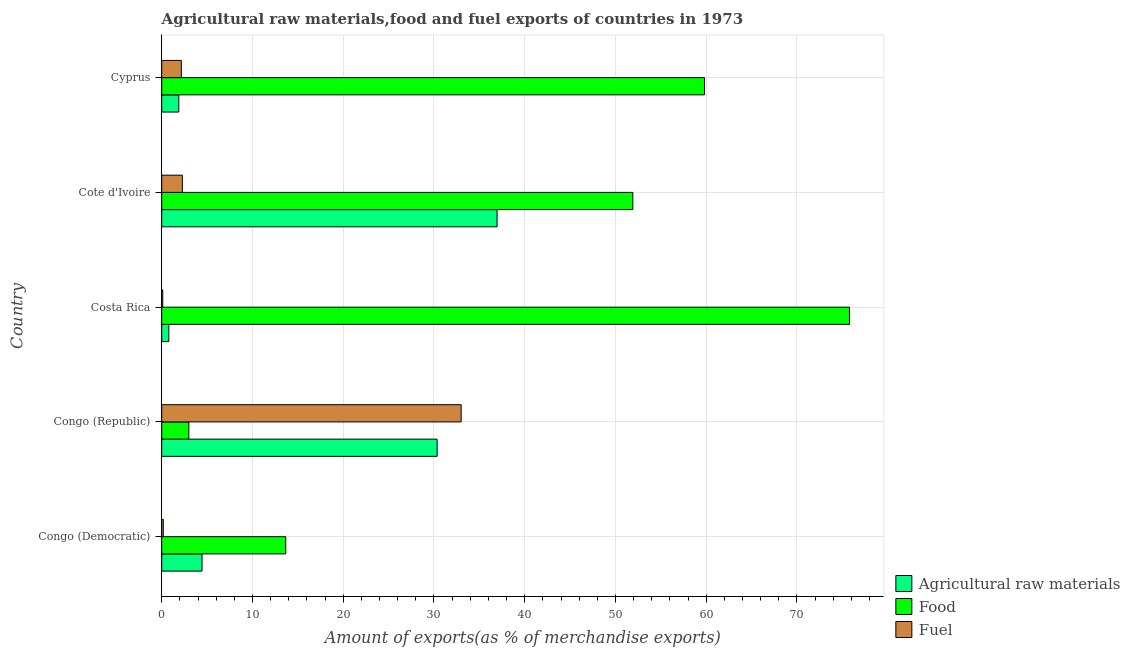How many different coloured bars are there?
Your answer should be very brief. 3. How many groups of bars are there?
Your answer should be very brief. 5. Are the number of bars per tick equal to the number of legend labels?
Provide a succinct answer. Yes. Are the number of bars on each tick of the Y-axis equal?
Make the answer very short. Yes. What is the label of the 1st group of bars from the top?
Offer a terse response. Cyprus. What is the percentage of raw materials exports in Congo (Democratic)?
Keep it short and to the point. 4.44. Across all countries, what is the maximum percentage of food exports?
Make the answer very short. 75.78. Across all countries, what is the minimum percentage of raw materials exports?
Provide a succinct answer. 0.78. In which country was the percentage of food exports maximum?
Your answer should be compact. Costa Rica. In which country was the percentage of food exports minimum?
Keep it short and to the point. Congo (Republic). What is the total percentage of raw materials exports in the graph?
Provide a short and direct response. 74.41. What is the difference between the percentage of raw materials exports in Congo (Democratic) and that in Cote d'Ivoire?
Keep it short and to the point. -32.51. What is the difference between the percentage of fuel exports in Costa Rica and the percentage of raw materials exports in Congo (Democratic)?
Make the answer very short. -4.33. What is the average percentage of fuel exports per country?
Provide a succinct answer. 7.54. What is the difference between the percentage of fuel exports and percentage of food exports in Cote d'Ivoire?
Your response must be concise. -49.63. What is the ratio of the percentage of raw materials exports in Congo (Republic) to that in Costa Rica?
Ensure brevity in your answer.  38.8. What is the difference between the highest and the second highest percentage of fuel exports?
Ensure brevity in your answer.  30.72. What is the difference between the highest and the lowest percentage of fuel exports?
Your answer should be very brief. 32.88. What does the 3rd bar from the top in Cyprus represents?
Your answer should be compact. Agricultural raw materials. What does the 2nd bar from the bottom in Congo (Democratic) represents?
Make the answer very short. Food. How many bars are there?
Your answer should be compact. 15. Are all the bars in the graph horizontal?
Make the answer very short. Yes. How many countries are there in the graph?
Give a very brief answer. 5. Are the values on the major ticks of X-axis written in scientific E-notation?
Offer a terse response. No. Does the graph contain any zero values?
Offer a terse response. No. How many legend labels are there?
Your answer should be very brief. 3. How are the legend labels stacked?
Give a very brief answer. Vertical. What is the title of the graph?
Your answer should be very brief. Agricultural raw materials,food and fuel exports of countries in 1973. Does "Agricultural Nitrous Oxide" appear as one of the legend labels in the graph?
Ensure brevity in your answer.  No. What is the label or title of the X-axis?
Your response must be concise. Amount of exports(as % of merchandise exports). What is the label or title of the Y-axis?
Keep it short and to the point. Country. What is the Amount of exports(as % of merchandise exports) of Agricultural raw materials in Congo (Democratic)?
Keep it short and to the point. 4.44. What is the Amount of exports(as % of merchandise exports) of Food in Congo (Democratic)?
Your answer should be compact. 13.67. What is the Amount of exports(as % of merchandise exports) of Fuel in Congo (Democratic)?
Your answer should be very brief. 0.18. What is the Amount of exports(as % of merchandise exports) of Agricultural raw materials in Congo (Republic)?
Offer a terse response. 30.35. What is the Amount of exports(as % of merchandise exports) of Food in Congo (Republic)?
Provide a short and direct response. 2.99. What is the Amount of exports(as % of merchandise exports) in Fuel in Congo (Republic)?
Offer a terse response. 33. What is the Amount of exports(as % of merchandise exports) of Agricultural raw materials in Costa Rica?
Ensure brevity in your answer.  0.78. What is the Amount of exports(as % of merchandise exports) in Food in Costa Rica?
Provide a succinct answer. 75.78. What is the Amount of exports(as % of merchandise exports) of Fuel in Costa Rica?
Give a very brief answer. 0.11. What is the Amount of exports(as % of merchandise exports) of Agricultural raw materials in Cote d'Ivoire?
Keep it short and to the point. 36.95. What is the Amount of exports(as % of merchandise exports) in Food in Cote d'Ivoire?
Keep it short and to the point. 51.91. What is the Amount of exports(as % of merchandise exports) in Fuel in Cote d'Ivoire?
Offer a very short reply. 2.28. What is the Amount of exports(as % of merchandise exports) in Agricultural raw materials in Cyprus?
Provide a succinct answer. 1.88. What is the Amount of exports(as % of merchandise exports) in Food in Cyprus?
Provide a succinct answer. 59.81. What is the Amount of exports(as % of merchandise exports) of Fuel in Cyprus?
Your answer should be compact. 2.16. Across all countries, what is the maximum Amount of exports(as % of merchandise exports) of Agricultural raw materials?
Offer a terse response. 36.95. Across all countries, what is the maximum Amount of exports(as % of merchandise exports) in Food?
Provide a short and direct response. 75.78. Across all countries, what is the maximum Amount of exports(as % of merchandise exports) of Fuel?
Ensure brevity in your answer.  33. Across all countries, what is the minimum Amount of exports(as % of merchandise exports) of Agricultural raw materials?
Your answer should be very brief. 0.78. Across all countries, what is the minimum Amount of exports(as % of merchandise exports) of Food?
Ensure brevity in your answer.  2.99. Across all countries, what is the minimum Amount of exports(as % of merchandise exports) in Fuel?
Your answer should be compact. 0.11. What is the total Amount of exports(as % of merchandise exports) of Agricultural raw materials in the graph?
Make the answer very short. 74.41. What is the total Amount of exports(as % of merchandise exports) in Food in the graph?
Offer a terse response. 204.15. What is the total Amount of exports(as % of merchandise exports) in Fuel in the graph?
Offer a very short reply. 37.72. What is the difference between the Amount of exports(as % of merchandise exports) of Agricultural raw materials in Congo (Democratic) and that in Congo (Republic)?
Offer a terse response. -25.91. What is the difference between the Amount of exports(as % of merchandise exports) of Food in Congo (Democratic) and that in Congo (Republic)?
Provide a short and direct response. 10.68. What is the difference between the Amount of exports(as % of merchandise exports) in Fuel in Congo (Democratic) and that in Congo (Republic)?
Your response must be concise. -32.82. What is the difference between the Amount of exports(as % of merchandise exports) of Agricultural raw materials in Congo (Democratic) and that in Costa Rica?
Keep it short and to the point. 3.66. What is the difference between the Amount of exports(as % of merchandise exports) in Food in Congo (Democratic) and that in Costa Rica?
Your answer should be very brief. -62.12. What is the difference between the Amount of exports(as % of merchandise exports) of Fuel in Congo (Democratic) and that in Costa Rica?
Keep it short and to the point. 0.06. What is the difference between the Amount of exports(as % of merchandise exports) in Agricultural raw materials in Congo (Democratic) and that in Cote d'Ivoire?
Give a very brief answer. -32.51. What is the difference between the Amount of exports(as % of merchandise exports) in Food in Congo (Democratic) and that in Cote d'Ivoire?
Offer a terse response. -38.25. What is the difference between the Amount of exports(as % of merchandise exports) of Fuel in Congo (Democratic) and that in Cote d'Ivoire?
Make the answer very short. -2.1. What is the difference between the Amount of exports(as % of merchandise exports) in Agricultural raw materials in Congo (Democratic) and that in Cyprus?
Offer a very short reply. 2.56. What is the difference between the Amount of exports(as % of merchandise exports) in Food in Congo (Democratic) and that in Cyprus?
Give a very brief answer. -46.14. What is the difference between the Amount of exports(as % of merchandise exports) of Fuel in Congo (Democratic) and that in Cyprus?
Provide a short and direct response. -1.99. What is the difference between the Amount of exports(as % of merchandise exports) in Agricultural raw materials in Congo (Republic) and that in Costa Rica?
Offer a very short reply. 29.57. What is the difference between the Amount of exports(as % of merchandise exports) in Food in Congo (Republic) and that in Costa Rica?
Your answer should be very brief. -72.79. What is the difference between the Amount of exports(as % of merchandise exports) in Fuel in Congo (Republic) and that in Costa Rica?
Give a very brief answer. 32.88. What is the difference between the Amount of exports(as % of merchandise exports) in Agricultural raw materials in Congo (Republic) and that in Cote d'Ivoire?
Offer a terse response. -6.6. What is the difference between the Amount of exports(as % of merchandise exports) of Food in Congo (Republic) and that in Cote d'Ivoire?
Ensure brevity in your answer.  -48.92. What is the difference between the Amount of exports(as % of merchandise exports) of Fuel in Congo (Republic) and that in Cote d'Ivoire?
Ensure brevity in your answer.  30.72. What is the difference between the Amount of exports(as % of merchandise exports) of Agricultural raw materials in Congo (Republic) and that in Cyprus?
Keep it short and to the point. 28.47. What is the difference between the Amount of exports(as % of merchandise exports) in Food in Congo (Republic) and that in Cyprus?
Your answer should be very brief. -56.82. What is the difference between the Amount of exports(as % of merchandise exports) in Fuel in Congo (Republic) and that in Cyprus?
Give a very brief answer. 30.83. What is the difference between the Amount of exports(as % of merchandise exports) in Agricultural raw materials in Costa Rica and that in Cote d'Ivoire?
Your answer should be compact. -36.17. What is the difference between the Amount of exports(as % of merchandise exports) of Food in Costa Rica and that in Cote d'Ivoire?
Ensure brevity in your answer.  23.87. What is the difference between the Amount of exports(as % of merchandise exports) in Fuel in Costa Rica and that in Cote d'Ivoire?
Your response must be concise. -2.16. What is the difference between the Amount of exports(as % of merchandise exports) in Agricultural raw materials in Costa Rica and that in Cyprus?
Offer a terse response. -1.1. What is the difference between the Amount of exports(as % of merchandise exports) of Food in Costa Rica and that in Cyprus?
Your answer should be compact. 15.97. What is the difference between the Amount of exports(as % of merchandise exports) of Fuel in Costa Rica and that in Cyprus?
Provide a succinct answer. -2.05. What is the difference between the Amount of exports(as % of merchandise exports) in Agricultural raw materials in Cote d'Ivoire and that in Cyprus?
Make the answer very short. 35.07. What is the difference between the Amount of exports(as % of merchandise exports) in Food in Cote d'Ivoire and that in Cyprus?
Make the answer very short. -7.9. What is the difference between the Amount of exports(as % of merchandise exports) of Fuel in Cote d'Ivoire and that in Cyprus?
Make the answer very short. 0.12. What is the difference between the Amount of exports(as % of merchandise exports) in Agricultural raw materials in Congo (Democratic) and the Amount of exports(as % of merchandise exports) in Food in Congo (Republic)?
Offer a terse response. 1.45. What is the difference between the Amount of exports(as % of merchandise exports) in Agricultural raw materials in Congo (Democratic) and the Amount of exports(as % of merchandise exports) in Fuel in Congo (Republic)?
Your response must be concise. -28.55. What is the difference between the Amount of exports(as % of merchandise exports) of Food in Congo (Democratic) and the Amount of exports(as % of merchandise exports) of Fuel in Congo (Republic)?
Offer a terse response. -19.33. What is the difference between the Amount of exports(as % of merchandise exports) in Agricultural raw materials in Congo (Democratic) and the Amount of exports(as % of merchandise exports) in Food in Costa Rica?
Ensure brevity in your answer.  -71.34. What is the difference between the Amount of exports(as % of merchandise exports) of Agricultural raw materials in Congo (Democratic) and the Amount of exports(as % of merchandise exports) of Fuel in Costa Rica?
Ensure brevity in your answer.  4.33. What is the difference between the Amount of exports(as % of merchandise exports) of Food in Congo (Democratic) and the Amount of exports(as % of merchandise exports) of Fuel in Costa Rica?
Offer a terse response. 13.55. What is the difference between the Amount of exports(as % of merchandise exports) of Agricultural raw materials in Congo (Democratic) and the Amount of exports(as % of merchandise exports) of Food in Cote d'Ivoire?
Make the answer very short. -47.47. What is the difference between the Amount of exports(as % of merchandise exports) in Agricultural raw materials in Congo (Democratic) and the Amount of exports(as % of merchandise exports) in Fuel in Cote d'Ivoire?
Ensure brevity in your answer.  2.16. What is the difference between the Amount of exports(as % of merchandise exports) of Food in Congo (Democratic) and the Amount of exports(as % of merchandise exports) of Fuel in Cote d'Ivoire?
Provide a short and direct response. 11.39. What is the difference between the Amount of exports(as % of merchandise exports) of Agricultural raw materials in Congo (Democratic) and the Amount of exports(as % of merchandise exports) of Food in Cyprus?
Your answer should be very brief. -55.36. What is the difference between the Amount of exports(as % of merchandise exports) of Agricultural raw materials in Congo (Democratic) and the Amount of exports(as % of merchandise exports) of Fuel in Cyprus?
Make the answer very short. 2.28. What is the difference between the Amount of exports(as % of merchandise exports) in Food in Congo (Democratic) and the Amount of exports(as % of merchandise exports) in Fuel in Cyprus?
Your answer should be compact. 11.5. What is the difference between the Amount of exports(as % of merchandise exports) of Agricultural raw materials in Congo (Republic) and the Amount of exports(as % of merchandise exports) of Food in Costa Rica?
Provide a succinct answer. -45.43. What is the difference between the Amount of exports(as % of merchandise exports) of Agricultural raw materials in Congo (Republic) and the Amount of exports(as % of merchandise exports) of Fuel in Costa Rica?
Provide a succinct answer. 30.23. What is the difference between the Amount of exports(as % of merchandise exports) in Food in Congo (Republic) and the Amount of exports(as % of merchandise exports) in Fuel in Costa Rica?
Provide a succinct answer. 2.87. What is the difference between the Amount of exports(as % of merchandise exports) in Agricultural raw materials in Congo (Republic) and the Amount of exports(as % of merchandise exports) in Food in Cote d'Ivoire?
Offer a terse response. -21.56. What is the difference between the Amount of exports(as % of merchandise exports) of Agricultural raw materials in Congo (Republic) and the Amount of exports(as % of merchandise exports) of Fuel in Cote d'Ivoire?
Your response must be concise. 28.07. What is the difference between the Amount of exports(as % of merchandise exports) of Food in Congo (Republic) and the Amount of exports(as % of merchandise exports) of Fuel in Cote d'Ivoire?
Ensure brevity in your answer.  0.71. What is the difference between the Amount of exports(as % of merchandise exports) in Agricultural raw materials in Congo (Republic) and the Amount of exports(as % of merchandise exports) in Food in Cyprus?
Ensure brevity in your answer.  -29.46. What is the difference between the Amount of exports(as % of merchandise exports) in Agricultural raw materials in Congo (Republic) and the Amount of exports(as % of merchandise exports) in Fuel in Cyprus?
Provide a succinct answer. 28.19. What is the difference between the Amount of exports(as % of merchandise exports) in Food in Congo (Republic) and the Amount of exports(as % of merchandise exports) in Fuel in Cyprus?
Offer a very short reply. 0.83. What is the difference between the Amount of exports(as % of merchandise exports) of Agricultural raw materials in Costa Rica and the Amount of exports(as % of merchandise exports) of Food in Cote d'Ivoire?
Provide a short and direct response. -51.13. What is the difference between the Amount of exports(as % of merchandise exports) in Agricultural raw materials in Costa Rica and the Amount of exports(as % of merchandise exports) in Fuel in Cote d'Ivoire?
Your answer should be compact. -1.5. What is the difference between the Amount of exports(as % of merchandise exports) of Food in Costa Rica and the Amount of exports(as % of merchandise exports) of Fuel in Cote d'Ivoire?
Provide a succinct answer. 73.5. What is the difference between the Amount of exports(as % of merchandise exports) of Agricultural raw materials in Costa Rica and the Amount of exports(as % of merchandise exports) of Food in Cyprus?
Offer a very short reply. -59.02. What is the difference between the Amount of exports(as % of merchandise exports) in Agricultural raw materials in Costa Rica and the Amount of exports(as % of merchandise exports) in Fuel in Cyprus?
Make the answer very short. -1.38. What is the difference between the Amount of exports(as % of merchandise exports) of Food in Costa Rica and the Amount of exports(as % of merchandise exports) of Fuel in Cyprus?
Give a very brief answer. 73.62. What is the difference between the Amount of exports(as % of merchandise exports) of Agricultural raw materials in Cote d'Ivoire and the Amount of exports(as % of merchandise exports) of Food in Cyprus?
Your answer should be compact. -22.85. What is the difference between the Amount of exports(as % of merchandise exports) in Agricultural raw materials in Cote d'Ivoire and the Amount of exports(as % of merchandise exports) in Fuel in Cyprus?
Keep it short and to the point. 34.79. What is the difference between the Amount of exports(as % of merchandise exports) in Food in Cote d'Ivoire and the Amount of exports(as % of merchandise exports) in Fuel in Cyprus?
Your answer should be compact. 49.75. What is the average Amount of exports(as % of merchandise exports) of Agricultural raw materials per country?
Offer a terse response. 14.88. What is the average Amount of exports(as % of merchandise exports) of Food per country?
Your answer should be compact. 40.83. What is the average Amount of exports(as % of merchandise exports) of Fuel per country?
Provide a succinct answer. 7.54. What is the difference between the Amount of exports(as % of merchandise exports) of Agricultural raw materials and Amount of exports(as % of merchandise exports) of Food in Congo (Democratic)?
Ensure brevity in your answer.  -9.22. What is the difference between the Amount of exports(as % of merchandise exports) of Agricultural raw materials and Amount of exports(as % of merchandise exports) of Fuel in Congo (Democratic)?
Provide a succinct answer. 4.27. What is the difference between the Amount of exports(as % of merchandise exports) of Food and Amount of exports(as % of merchandise exports) of Fuel in Congo (Democratic)?
Your answer should be compact. 13.49. What is the difference between the Amount of exports(as % of merchandise exports) in Agricultural raw materials and Amount of exports(as % of merchandise exports) in Food in Congo (Republic)?
Your answer should be very brief. 27.36. What is the difference between the Amount of exports(as % of merchandise exports) of Agricultural raw materials and Amount of exports(as % of merchandise exports) of Fuel in Congo (Republic)?
Give a very brief answer. -2.65. What is the difference between the Amount of exports(as % of merchandise exports) in Food and Amount of exports(as % of merchandise exports) in Fuel in Congo (Republic)?
Your answer should be compact. -30.01. What is the difference between the Amount of exports(as % of merchandise exports) in Agricultural raw materials and Amount of exports(as % of merchandise exports) in Food in Costa Rica?
Provide a succinct answer. -75. What is the difference between the Amount of exports(as % of merchandise exports) in Agricultural raw materials and Amount of exports(as % of merchandise exports) in Fuel in Costa Rica?
Provide a succinct answer. 0.67. What is the difference between the Amount of exports(as % of merchandise exports) in Food and Amount of exports(as % of merchandise exports) in Fuel in Costa Rica?
Make the answer very short. 75.67. What is the difference between the Amount of exports(as % of merchandise exports) in Agricultural raw materials and Amount of exports(as % of merchandise exports) in Food in Cote d'Ivoire?
Your response must be concise. -14.96. What is the difference between the Amount of exports(as % of merchandise exports) in Agricultural raw materials and Amount of exports(as % of merchandise exports) in Fuel in Cote d'Ivoire?
Offer a terse response. 34.68. What is the difference between the Amount of exports(as % of merchandise exports) in Food and Amount of exports(as % of merchandise exports) in Fuel in Cote d'Ivoire?
Your response must be concise. 49.63. What is the difference between the Amount of exports(as % of merchandise exports) in Agricultural raw materials and Amount of exports(as % of merchandise exports) in Food in Cyprus?
Give a very brief answer. -57.92. What is the difference between the Amount of exports(as % of merchandise exports) in Agricultural raw materials and Amount of exports(as % of merchandise exports) in Fuel in Cyprus?
Keep it short and to the point. -0.28. What is the difference between the Amount of exports(as % of merchandise exports) in Food and Amount of exports(as % of merchandise exports) in Fuel in Cyprus?
Offer a very short reply. 57.65. What is the ratio of the Amount of exports(as % of merchandise exports) of Agricultural raw materials in Congo (Democratic) to that in Congo (Republic)?
Keep it short and to the point. 0.15. What is the ratio of the Amount of exports(as % of merchandise exports) in Food in Congo (Democratic) to that in Congo (Republic)?
Give a very brief answer. 4.57. What is the ratio of the Amount of exports(as % of merchandise exports) of Fuel in Congo (Democratic) to that in Congo (Republic)?
Make the answer very short. 0.01. What is the ratio of the Amount of exports(as % of merchandise exports) in Agricultural raw materials in Congo (Democratic) to that in Costa Rica?
Offer a terse response. 5.68. What is the ratio of the Amount of exports(as % of merchandise exports) of Food in Congo (Democratic) to that in Costa Rica?
Keep it short and to the point. 0.18. What is the ratio of the Amount of exports(as % of merchandise exports) in Fuel in Congo (Democratic) to that in Costa Rica?
Give a very brief answer. 1.53. What is the ratio of the Amount of exports(as % of merchandise exports) in Agricultural raw materials in Congo (Democratic) to that in Cote d'Ivoire?
Your answer should be compact. 0.12. What is the ratio of the Amount of exports(as % of merchandise exports) of Food in Congo (Democratic) to that in Cote d'Ivoire?
Your answer should be very brief. 0.26. What is the ratio of the Amount of exports(as % of merchandise exports) of Fuel in Congo (Democratic) to that in Cote d'Ivoire?
Keep it short and to the point. 0.08. What is the ratio of the Amount of exports(as % of merchandise exports) of Agricultural raw materials in Congo (Democratic) to that in Cyprus?
Ensure brevity in your answer.  2.36. What is the ratio of the Amount of exports(as % of merchandise exports) in Food in Congo (Democratic) to that in Cyprus?
Your answer should be very brief. 0.23. What is the ratio of the Amount of exports(as % of merchandise exports) of Fuel in Congo (Democratic) to that in Cyprus?
Ensure brevity in your answer.  0.08. What is the ratio of the Amount of exports(as % of merchandise exports) of Agricultural raw materials in Congo (Republic) to that in Costa Rica?
Your response must be concise. 38.8. What is the ratio of the Amount of exports(as % of merchandise exports) in Food in Congo (Republic) to that in Costa Rica?
Ensure brevity in your answer.  0.04. What is the ratio of the Amount of exports(as % of merchandise exports) in Fuel in Congo (Republic) to that in Costa Rica?
Your response must be concise. 287.58. What is the ratio of the Amount of exports(as % of merchandise exports) of Agricultural raw materials in Congo (Republic) to that in Cote d'Ivoire?
Keep it short and to the point. 0.82. What is the ratio of the Amount of exports(as % of merchandise exports) of Food in Congo (Republic) to that in Cote d'Ivoire?
Offer a very short reply. 0.06. What is the ratio of the Amount of exports(as % of merchandise exports) of Fuel in Congo (Republic) to that in Cote d'Ivoire?
Ensure brevity in your answer.  14.48. What is the ratio of the Amount of exports(as % of merchandise exports) in Agricultural raw materials in Congo (Republic) to that in Cyprus?
Give a very brief answer. 16.12. What is the ratio of the Amount of exports(as % of merchandise exports) of Fuel in Congo (Republic) to that in Cyprus?
Provide a succinct answer. 15.27. What is the ratio of the Amount of exports(as % of merchandise exports) in Agricultural raw materials in Costa Rica to that in Cote d'Ivoire?
Provide a short and direct response. 0.02. What is the ratio of the Amount of exports(as % of merchandise exports) in Food in Costa Rica to that in Cote d'Ivoire?
Ensure brevity in your answer.  1.46. What is the ratio of the Amount of exports(as % of merchandise exports) of Fuel in Costa Rica to that in Cote d'Ivoire?
Your answer should be very brief. 0.05. What is the ratio of the Amount of exports(as % of merchandise exports) of Agricultural raw materials in Costa Rica to that in Cyprus?
Your response must be concise. 0.42. What is the ratio of the Amount of exports(as % of merchandise exports) in Food in Costa Rica to that in Cyprus?
Ensure brevity in your answer.  1.27. What is the ratio of the Amount of exports(as % of merchandise exports) in Fuel in Costa Rica to that in Cyprus?
Provide a short and direct response. 0.05. What is the ratio of the Amount of exports(as % of merchandise exports) of Agricultural raw materials in Cote d'Ivoire to that in Cyprus?
Offer a very short reply. 19.62. What is the ratio of the Amount of exports(as % of merchandise exports) in Food in Cote d'Ivoire to that in Cyprus?
Provide a succinct answer. 0.87. What is the ratio of the Amount of exports(as % of merchandise exports) of Fuel in Cote d'Ivoire to that in Cyprus?
Provide a succinct answer. 1.05. What is the difference between the highest and the second highest Amount of exports(as % of merchandise exports) of Agricultural raw materials?
Your answer should be compact. 6.6. What is the difference between the highest and the second highest Amount of exports(as % of merchandise exports) in Food?
Offer a terse response. 15.97. What is the difference between the highest and the second highest Amount of exports(as % of merchandise exports) of Fuel?
Offer a very short reply. 30.72. What is the difference between the highest and the lowest Amount of exports(as % of merchandise exports) in Agricultural raw materials?
Your answer should be very brief. 36.17. What is the difference between the highest and the lowest Amount of exports(as % of merchandise exports) in Food?
Offer a terse response. 72.79. What is the difference between the highest and the lowest Amount of exports(as % of merchandise exports) in Fuel?
Your answer should be compact. 32.88. 